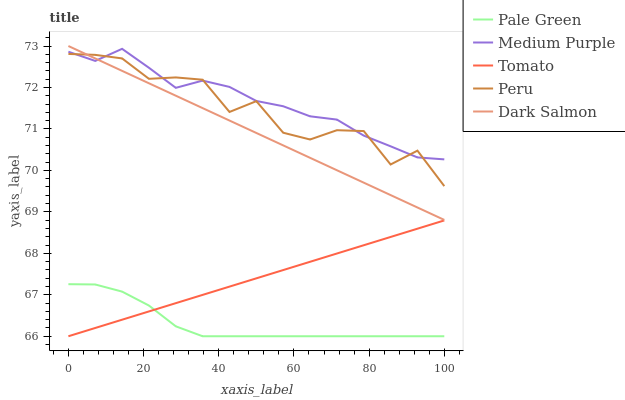Does Pale Green have the minimum area under the curve?
Answer yes or no. Yes. Does Medium Purple have the maximum area under the curve?
Answer yes or no. Yes. Does Tomato have the minimum area under the curve?
Answer yes or no. No. Does Tomato have the maximum area under the curve?
Answer yes or no. No. Is Dark Salmon the smoothest?
Answer yes or no. Yes. Is Peru the roughest?
Answer yes or no. Yes. Is Tomato the smoothest?
Answer yes or no. No. Is Tomato the roughest?
Answer yes or no. No. Does Dark Salmon have the lowest value?
Answer yes or no. No. Does Dark Salmon have the highest value?
Answer yes or no. Yes. Does Tomato have the highest value?
Answer yes or no. No. Is Tomato less than Dark Salmon?
Answer yes or no. Yes. Is Peru greater than Tomato?
Answer yes or no. Yes. Does Medium Purple intersect Peru?
Answer yes or no. Yes. Is Medium Purple less than Peru?
Answer yes or no. No. Is Medium Purple greater than Peru?
Answer yes or no. No. Does Tomato intersect Dark Salmon?
Answer yes or no. No. 